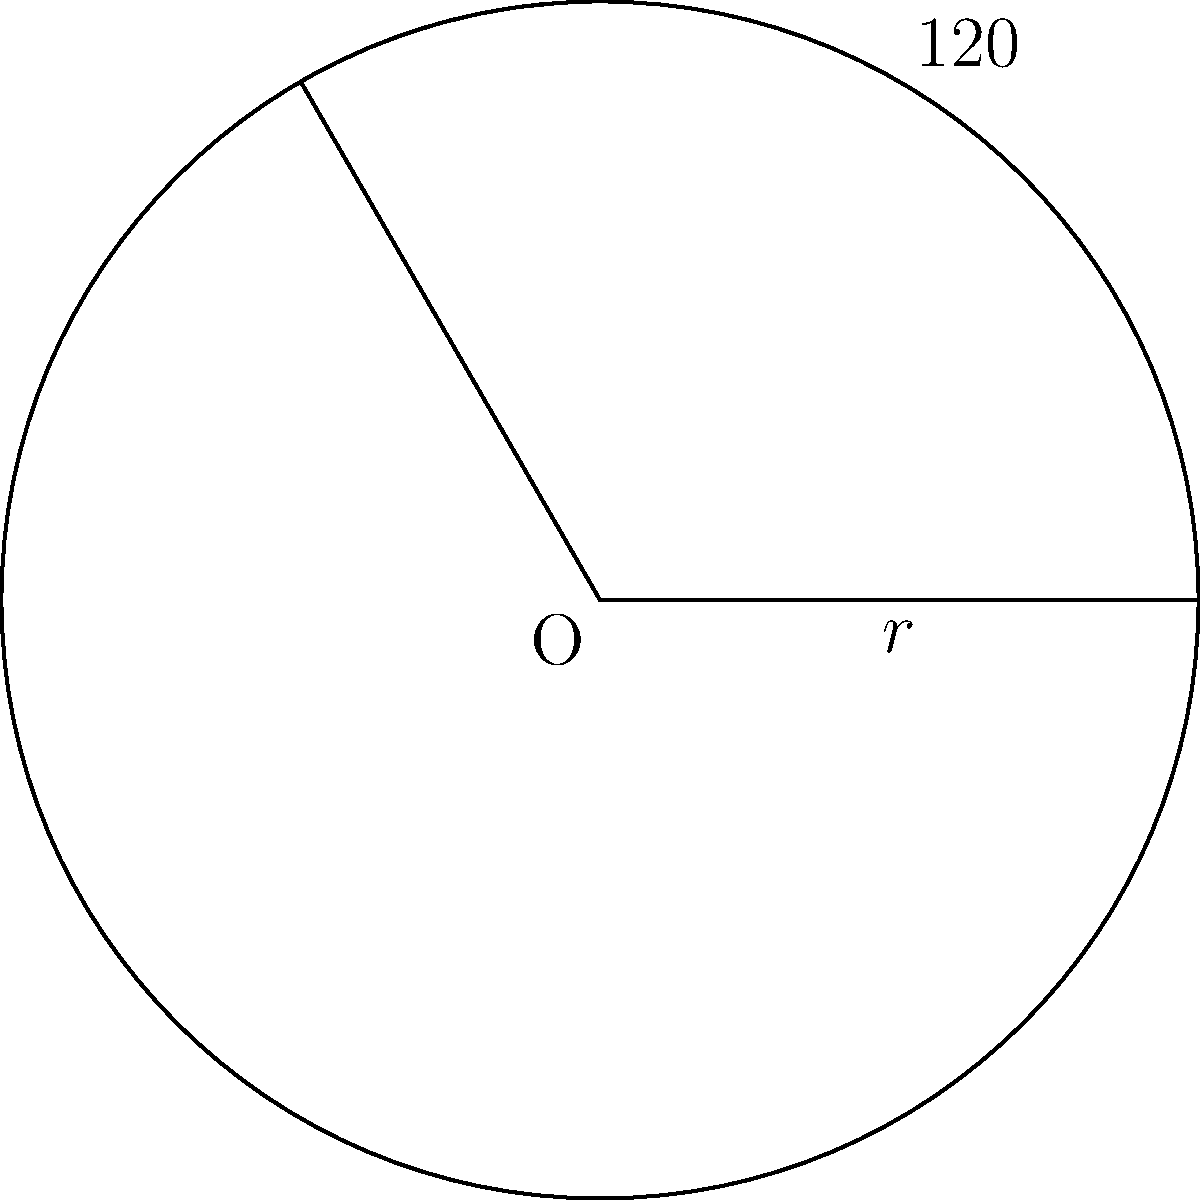In a circle with radius $r = 5$ cm, there is a central angle of $120°$. Calculate the length of the arc subtended by this angle. Use $\pi = 3.14$ for your calculations and round your answer to two decimal places. To solve this problem, we'll use the formula for arc length:

$$s = r \theta$$

Where:
$s$ = arc length
$r$ = radius of the circle
$\theta$ = central angle in radians

Steps:
1) We have $r = 5$ cm and the angle is $120°$. However, we need to convert the angle to radians.

2) To convert from degrees to radians, we use the formula:
   $$\theta_{rad} = \theta_{deg} \cdot \frac{\pi}{180°}$$

3) Substituting our values:
   $$\theta_{rad} = 120° \cdot \frac{\pi}{180°} = \frac{2\pi}{3} \approx 2.0944$$

4) Now we can use the arc length formula:
   $$s = r \theta = 5 \cdot \frac{2\pi}{3}$$

5) Simplifying:
   $$s = \frac{10\pi}{3}$$

6) Using $\pi = 3.14$:
   $$s = \frac{10 \cdot 3.14}{3} \approx 10.47$$

7) Rounding to two decimal places:
   $$s \approx 10.47 \text{ cm}$$
Answer: $10.47$ cm 